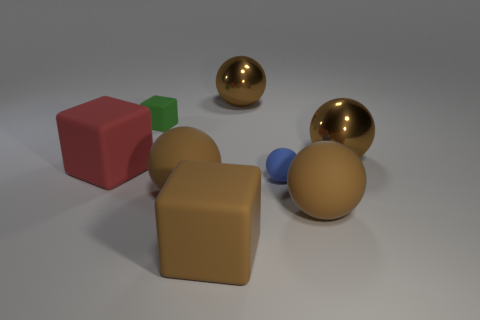How many other objects are the same color as the small rubber ball?
Provide a succinct answer. 0. How many things are either small cyan metallic objects or large brown spheres?
Your answer should be compact. 4. There is a green matte thing to the left of the blue rubber sphere; is it the same shape as the big red thing?
Offer a terse response. Yes. What color is the big matte block that is to the left of the tiny object to the left of the large brown matte cube?
Your answer should be compact. Red. Is the number of blue rubber objects less than the number of large metallic balls?
Offer a terse response. Yes. Are there any things that have the same material as the red cube?
Your answer should be very brief. Yes. Do the large red matte object and the blue object right of the big red cube have the same shape?
Provide a succinct answer. No. Are there any red matte objects behind the green rubber object?
Your answer should be very brief. No. How many brown metal objects are the same shape as the green object?
Offer a terse response. 0. Does the large brown cube have the same material as the tiny thing that is in front of the big red cube?
Make the answer very short. Yes. 